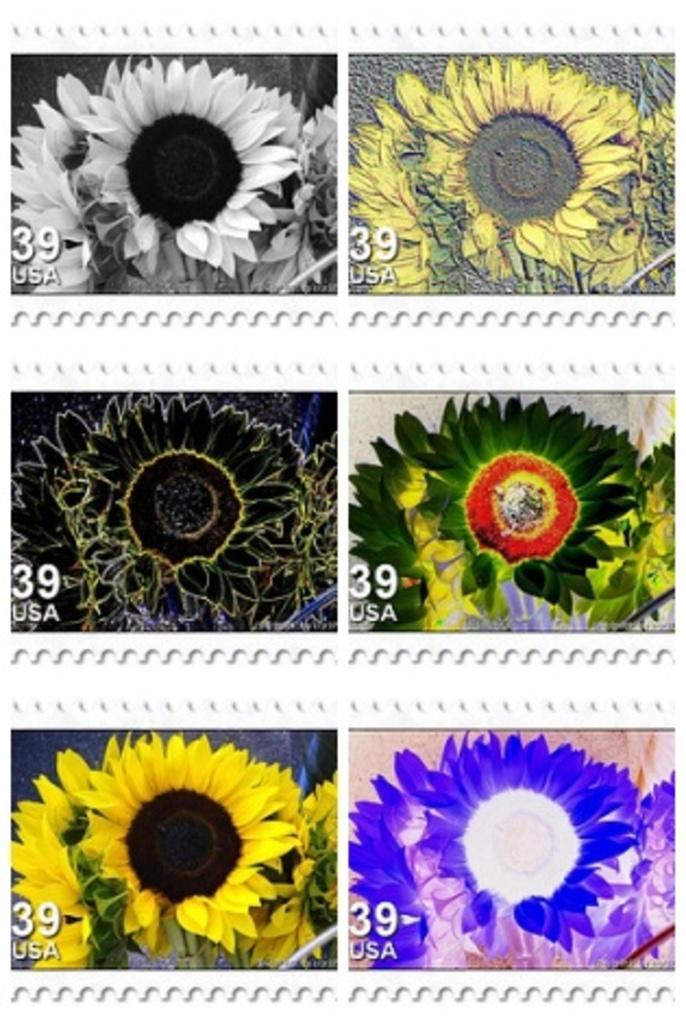What type of artwork is shown in the image? The image is a collage. What can be seen among the various elements in the collage? There are flowers of different colors in the image. Are there any words or phrases included in the collage? Yes, there is text present in the image. What type of thrill can be seen in the image? There is no thrill present in the image; it is a collage featuring flowers and text. Is there a baseball game happening in the image? No, there is no baseball game or any reference to baseball in the image. 